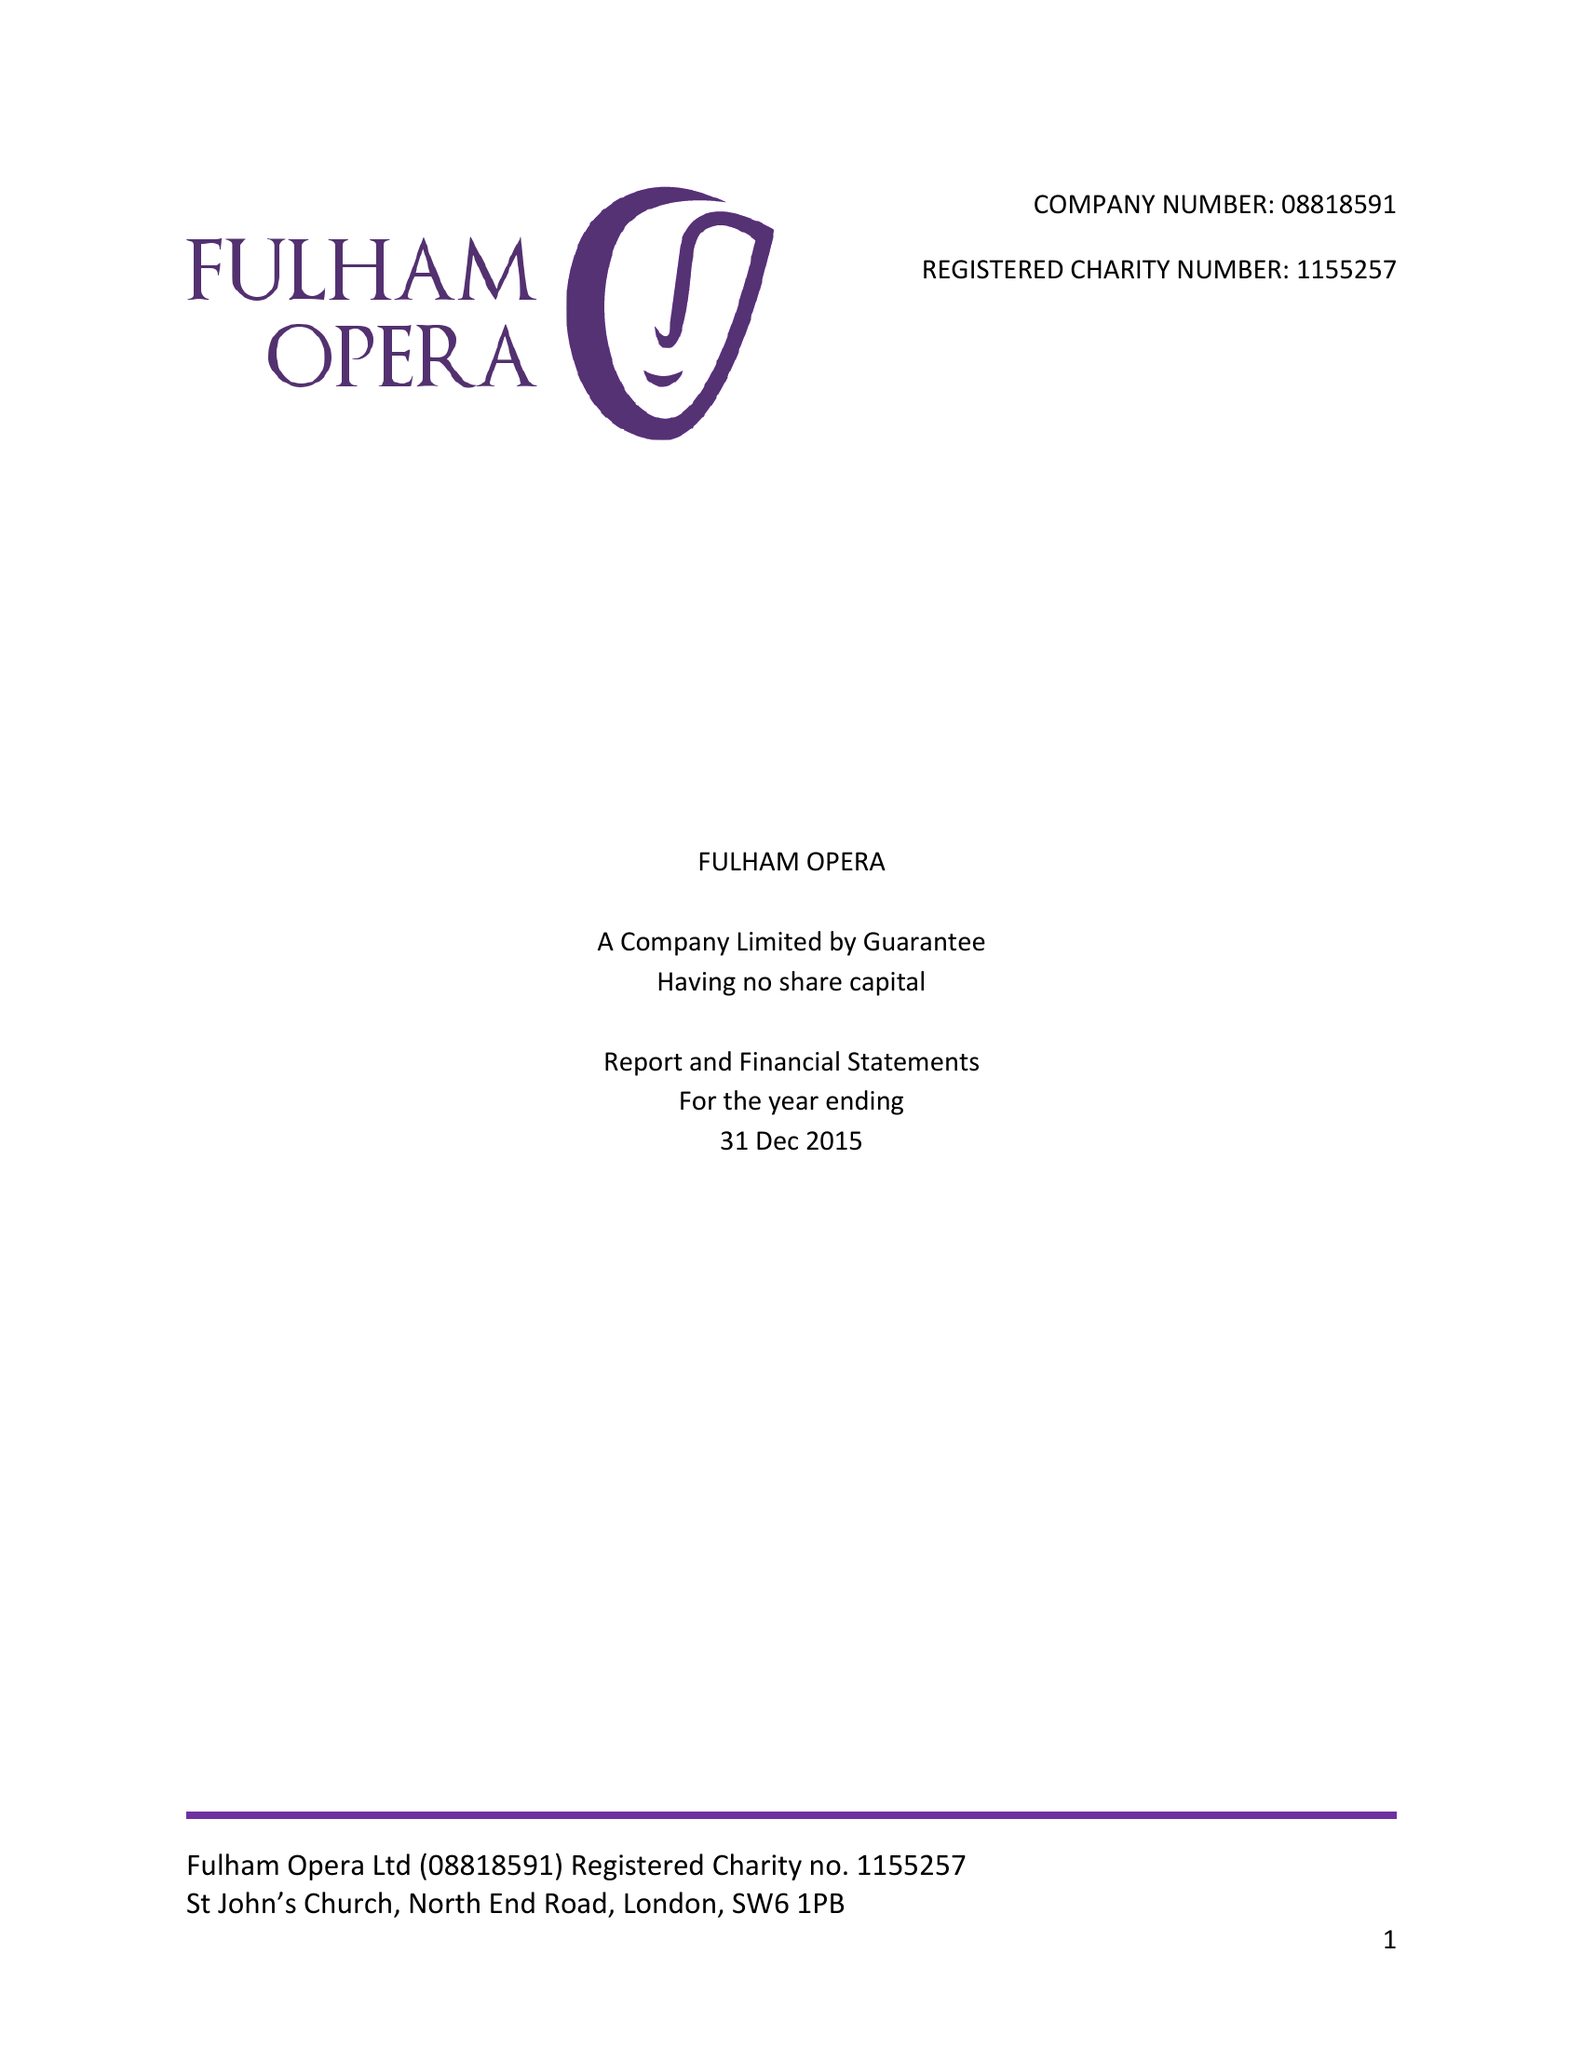What is the value for the charity_name?
Answer the question using a single word or phrase. Fulham Opera Ltd. 